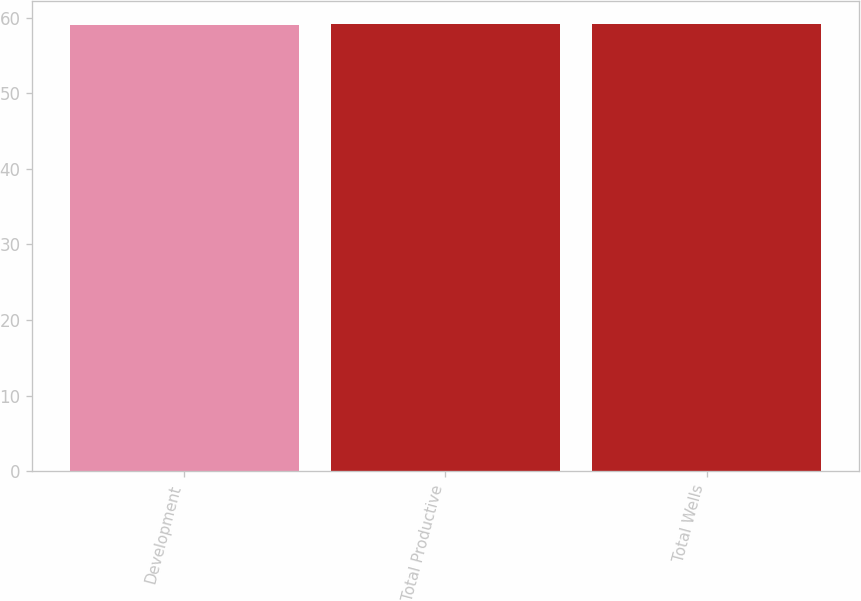Convert chart to OTSL. <chart><loc_0><loc_0><loc_500><loc_500><bar_chart><fcel>Development<fcel>Total Productive<fcel>Total Wells<nl><fcel>59<fcel>59.1<fcel>59.2<nl></chart> 